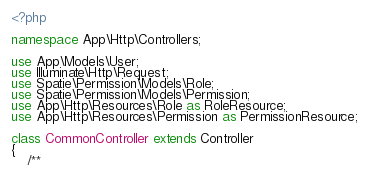<code> <loc_0><loc_0><loc_500><loc_500><_PHP_><?php

namespace App\Http\Controllers;

use App\Models\User;
use Illuminate\Http\Request;
use Spatie\Permission\Models\Role;
use Spatie\Permission\Models\Permission;
use App\Http\Resources\Role as RoleResource;
use App\Http\Resources\Permission as PermissionResource;

class CommonController extends Controller
{
    /**</code> 